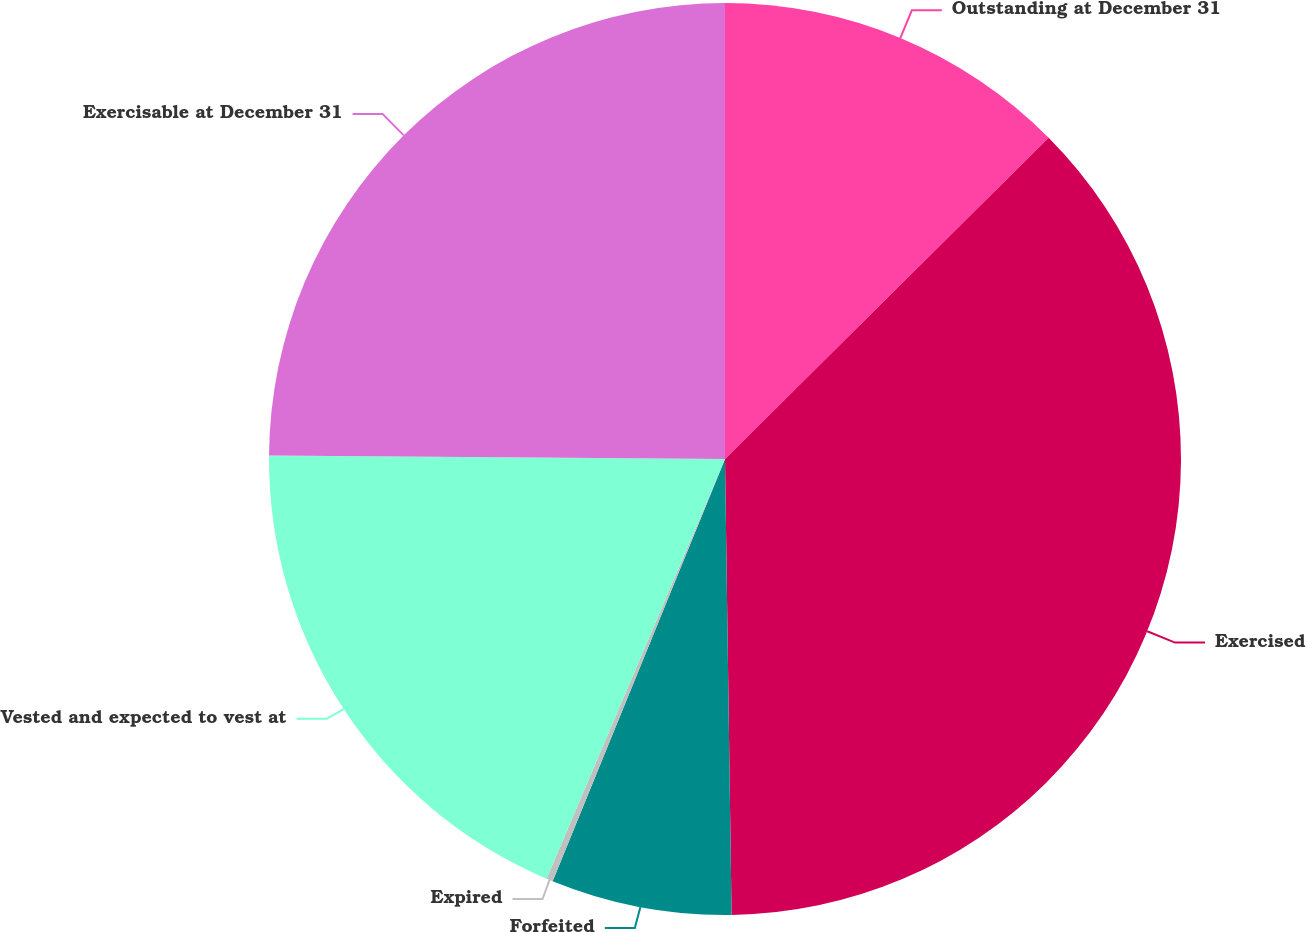Convert chart. <chart><loc_0><loc_0><loc_500><loc_500><pie_chart><fcel>Outstanding at December 31<fcel>Exercised<fcel>Forfeited<fcel>Expired<fcel>Vested and expected to vest at<fcel>Exercisable at December 31<nl><fcel>12.56%<fcel>37.21%<fcel>6.4%<fcel>0.23%<fcel>18.72%<fcel>24.88%<nl></chart> 